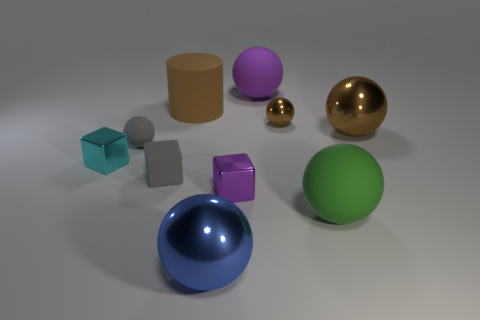Subtract all large matte spheres. How many spheres are left? 4 Subtract all yellow cylinders. How many brown spheres are left? 2 Subtract all green balls. How many balls are left? 5 Subtract 1 balls. How many balls are left? 5 Subtract all cylinders. How many objects are left? 9 Subtract all gray balls. Subtract all blue cylinders. How many balls are left? 5 Subtract all small blue cubes. Subtract all large brown objects. How many objects are left? 8 Add 3 purple metallic cubes. How many purple metallic cubes are left? 4 Add 9 big metal cubes. How many big metal cubes exist? 9 Subtract 1 purple balls. How many objects are left? 9 